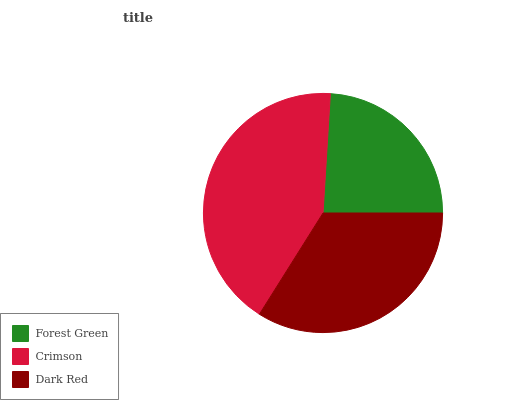Is Forest Green the minimum?
Answer yes or no. Yes. Is Crimson the maximum?
Answer yes or no. Yes. Is Dark Red the minimum?
Answer yes or no. No. Is Dark Red the maximum?
Answer yes or no. No. Is Crimson greater than Dark Red?
Answer yes or no. Yes. Is Dark Red less than Crimson?
Answer yes or no. Yes. Is Dark Red greater than Crimson?
Answer yes or no. No. Is Crimson less than Dark Red?
Answer yes or no. No. Is Dark Red the high median?
Answer yes or no. Yes. Is Dark Red the low median?
Answer yes or no. Yes. Is Crimson the high median?
Answer yes or no. No. Is Forest Green the low median?
Answer yes or no. No. 